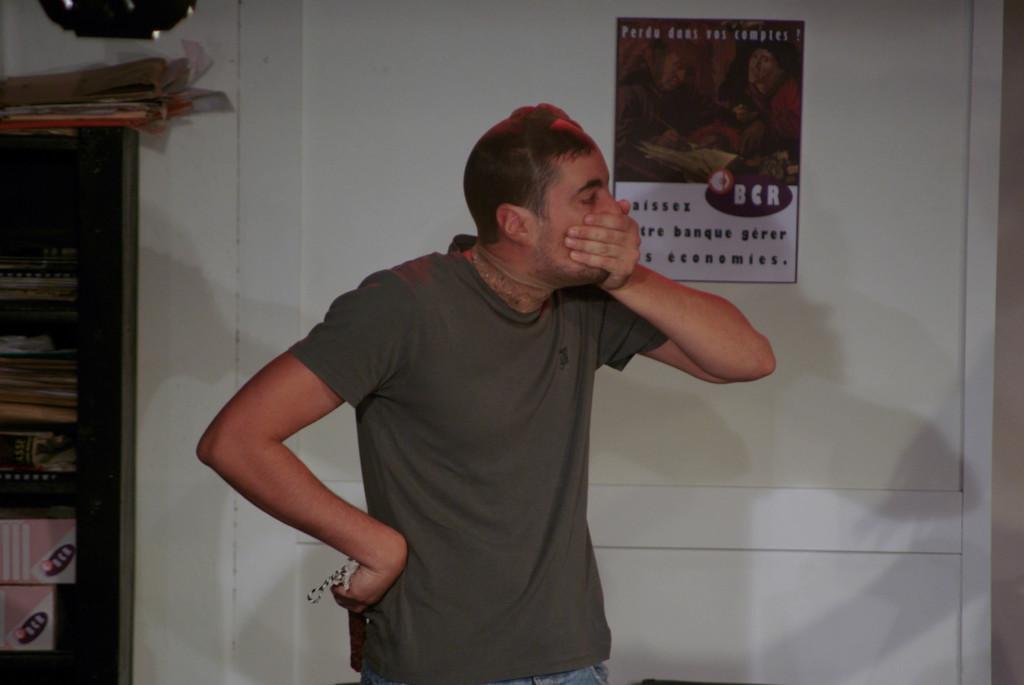What is on the poster?
Ensure brevity in your answer.  Bcr. 